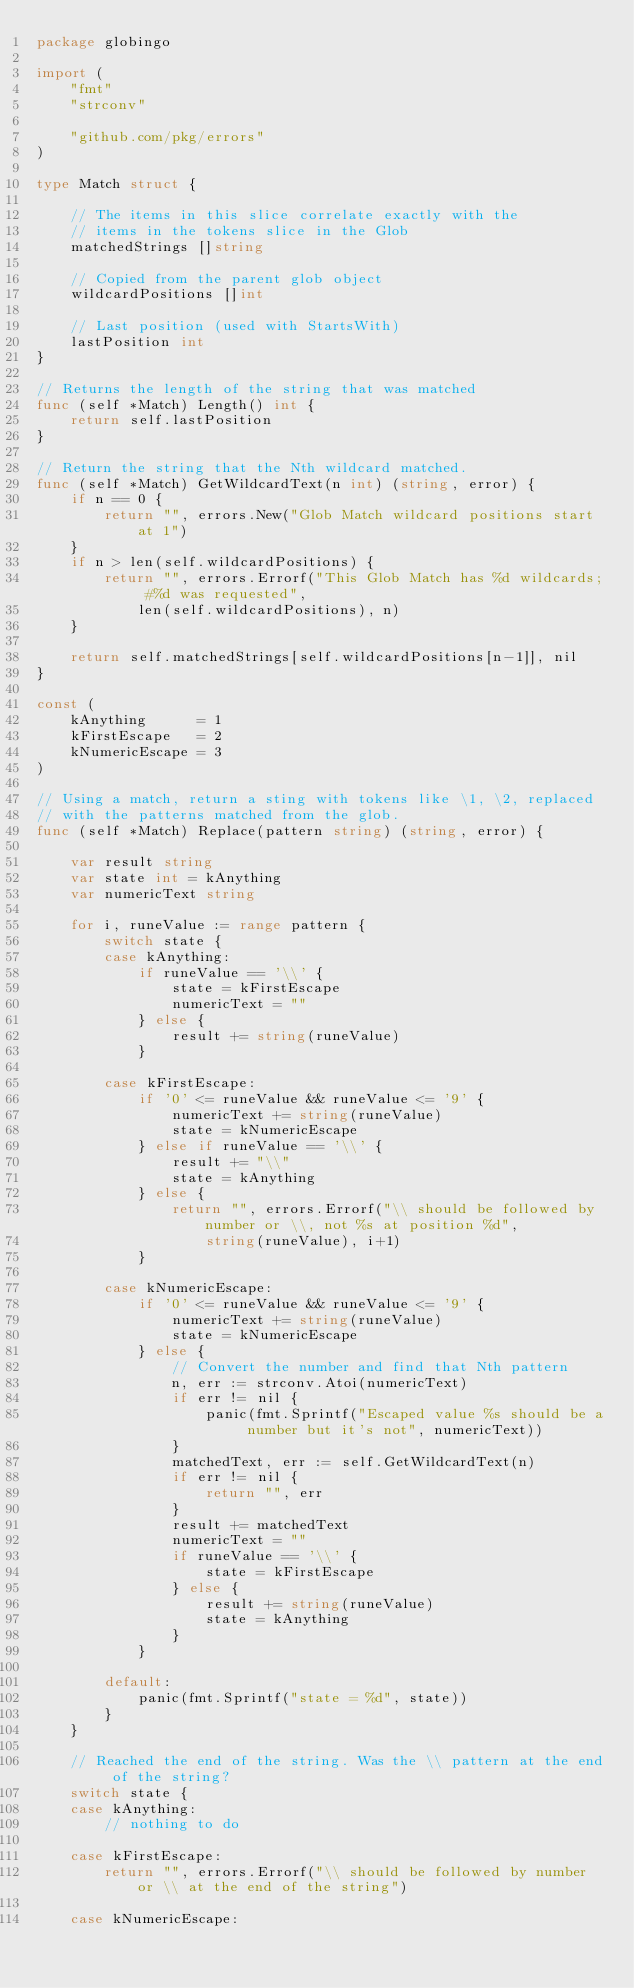Convert code to text. <code><loc_0><loc_0><loc_500><loc_500><_Go_>package globingo

import (
	"fmt"
	"strconv"

	"github.com/pkg/errors"
)

type Match struct {

	// The items in this slice correlate exactly with the
	// items in the tokens slice in the Glob
	matchedStrings []string

	// Copied from the parent glob object
	wildcardPositions []int

	// Last position (used with StartsWith)
	lastPosition int
}

// Returns the length of the string that was matched
func (self *Match) Length() int {
	return self.lastPosition
}

// Return the string that the Nth wildcard matched.
func (self *Match) GetWildcardText(n int) (string, error) {
	if n == 0 {
		return "", errors.New("Glob Match wildcard positions start at 1")
	}
	if n > len(self.wildcardPositions) {
		return "", errors.Errorf("This Glob Match has %d wildcards; #%d was requested",
			len(self.wildcardPositions), n)
	}

	return self.matchedStrings[self.wildcardPositions[n-1]], nil
}

const (
	kAnything      = 1
	kFirstEscape   = 2
	kNumericEscape = 3
)

// Using a match, return a sting with tokens like \1, \2, replaced
// with the patterns matched from the glob.
func (self *Match) Replace(pattern string) (string, error) {

	var result string
	var state int = kAnything
	var numericText string

	for i, runeValue := range pattern {
		switch state {
		case kAnything:
			if runeValue == '\\' {
				state = kFirstEscape
				numericText = ""
			} else {
				result += string(runeValue)
			}

		case kFirstEscape:
			if '0' <= runeValue && runeValue <= '9' {
				numericText += string(runeValue)
				state = kNumericEscape
			} else if runeValue == '\\' {
				result += "\\"
				state = kAnything
			} else {
				return "", errors.Errorf("\\ should be followed by number or \\, not %s at position %d",
					string(runeValue), i+1)
			}

		case kNumericEscape:
			if '0' <= runeValue && runeValue <= '9' {
				numericText += string(runeValue)
				state = kNumericEscape
			} else {
				// Convert the number and find that Nth pattern
				n, err := strconv.Atoi(numericText)
				if err != nil {
					panic(fmt.Sprintf("Escaped value %s should be a number but it's not", numericText))
				}
				matchedText, err := self.GetWildcardText(n)
				if err != nil {
					return "", err
				}
				result += matchedText
				numericText = ""
				if runeValue == '\\' {
					state = kFirstEscape
				} else {
					result += string(runeValue)
					state = kAnything
				}
			}

		default:
			panic(fmt.Sprintf("state = %d", state))
		}
	}

	// Reached the end of the string. Was the \\ pattern at the end of the string?
	switch state {
	case kAnything:
		// nothing to do

	case kFirstEscape:
		return "", errors.Errorf("\\ should be followed by number or \\ at the end of the string")

	case kNumericEscape:</code> 